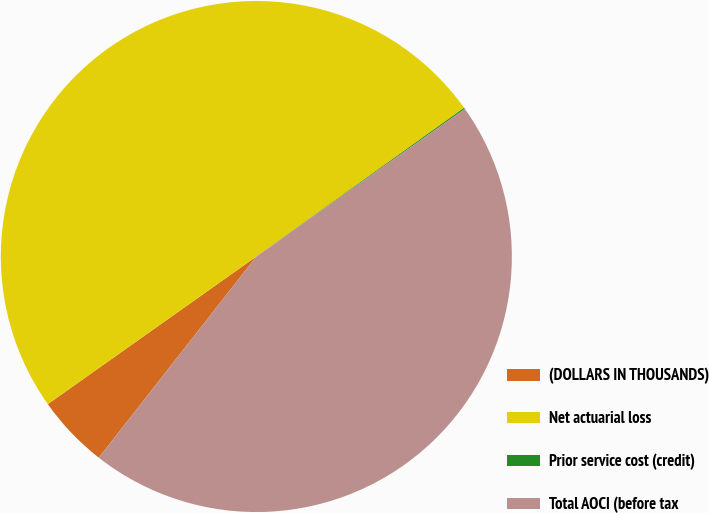Convert chart. <chart><loc_0><loc_0><loc_500><loc_500><pie_chart><fcel>(DOLLARS IN THOUSANDS)<fcel>Net actuarial loss<fcel>Prior service cost (credit)<fcel>Total AOCI (before tax<nl><fcel>4.62%<fcel>49.92%<fcel>0.08%<fcel>45.38%<nl></chart> 